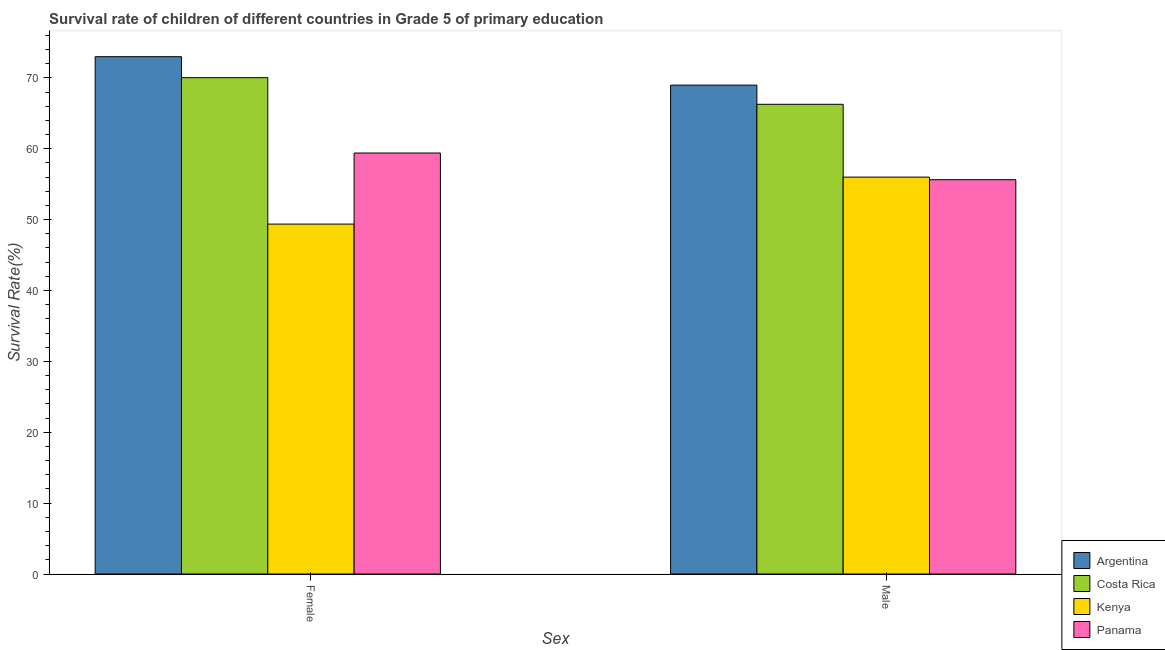How many different coloured bars are there?
Ensure brevity in your answer.  4. Are the number of bars per tick equal to the number of legend labels?
Provide a succinct answer. Yes. Are the number of bars on each tick of the X-axis equal?
Provide a short and direct response. Yes. How many bars are there on the 1st tick from the left?
Provide a succinct answer. 4. How many bars are there on the 1st tick from the right?
Make the answer very short. 4. What is the label of the 1st group of bars from the left?
Provide a succinct answer. Female. What is the survival rate of male students in primary education in Argentina?
Keep it short and to the point. 68.98. Across all countries, what is the maximum survival rate of male students in primary education?
Your answer should be very brief. 68.98. Across all countries, what is the minimum survival rate of male students in primary education?
Give a very brief answer. 55.63. In which country was the survival rate of female students in primary education minimum?
Offer a very short reply. Kenya. What is the total survival rate of female students in primary education in the graph?
Offer a terse response. 251.8. What is the difference between the survival rate of male students in primary education in Panama and that in Costa Rica?
Your answer should be very brief. -10.64. What is the difference between the survival rate of male students in primary education in Costa Rica and the survival rate of female students in primary education in Kenya?
Provide a succinct answer. 16.9. What is the average survival rate of male students in primary education per country?
Give a very brief answer. 61.72. What is the difference between the survival rate of female students in primary education and survival rate of male students in primary education in Argentina?
Provide a short and direct response. 4.01. What is the ratio of the survival rate of male students in primary education in Costa Rica to that in Panama?
Keep it short and to the point. 1.19. What does the 4th bar from the left in Female represents?
Your answer should be compact. Panama. Are all the bars in the graph horizontal?
Make the answer very short. No. What is the difference between two consecutive major ticks on the Y-axis?
Your response must be concise. 10. Are the values on the major ticks of Y-axis written in scientific E-notation?
Keep it short and to the point. No. Does the graph contain any zero values?
Offer a terse response. No. How are the legend labels stacked?
Offer a very short reply. Vertical. What is the title of the graph?
Offer a terse response. Survival rate of children of different countries in Grade 5 of primary education. What is the label or title of the X-axis?
Your answer should be compact. Sex. What is the label or title of the Y-axis?
Your answer should be compact. Survival Rate(%). What is the Survival Rate(%) of Argentina in Female?
Provide a succinct answer. 72.99. What is the Survival Rate(%) of Costa Rica in Female?
Ensure brevity in your answer.  70.03. What is the Survival Rate(%) of Kenya in Female?
Your answer should be compact. 49.37. What is the Survival Rate(%) of Panama in Female?
Provide a short and direct response. 59.4. What is the Survival Rate(%) of Argentina in Male?
Ensure brevity in your answer.  68.98. What is the Survival Rate(%) of Costa Rica in Male?
Ensure brevity in your answer.  66.27. What is the Survival Rate(%) in Kenya in Male?
Make the answer very short. 56. What is the Survival Rate(%) in Panama in Male?
Your answer should be very brief. 55.63. Across all Sex, what is the maximum Survival Rate(%) in Argentina?
Offer a very short reply. 72.99. Across all Sex, what is the maximum Survival Rate(%) in Costa Rica?
Ensure brevity in your answer.  70.03. Across all Sex, what is the maximum Survival Rate(%) of Kenya?
Your answer should be compact. 56. Across all Sex, what is the maximum Survival Rate(%) of Panama?
Offer a very short reply. 59.4. Across all Sex, what is the minimum Survival Rate(%) in Argentina?
Your response must be concise. 68.98. Across all Sex, what is the minimum Survival Rate(%) of Costa Rica?
Your answer should be compact. 66.27. Across all Sex, what is the minimum Survival Rate(%) in Kenya?
Make the answer very short. 49.37. Across all Sex, what is the minimum Survival Rate(%) of Panama?
Give a very brief answer. 55.63. What is the total Survival Rate(%) in Argentina in the graph?
Provide a short and direct response. 141.97. What is the total Survival Rate(%) in Costa Rica in the graph?
Offer a terse response. 136.31. What is the total Survival Rate(%) in Kenya in the graph?
Your answer should be compact. 105.37. What is the total Survival Rate(%) of Panama in the graph?
Ensure brevity in your answer.  115.04. What is the difference between the Survival Rate(%) in Argentina in Female and that in Male?
Offer a terse response. 4.01. What is the difference between the Survival Rate(%) in Costa Rica in Female and that in Male?
Offer a terse response. 3.76. What is the difference between the Survival Rate(%) in Kenya in Female and that in Male?
Provide a succinct answer. -6.63. What is the difference between the Survival Rate(%) of Panama in Female and that in Male?
Offer a very short reply. 3.77. What is the difference between the Survival Rate(%) in Argentina in Female and the Survival Rate(%) in Costa Rica in Male?
Make the answer very short. 6.72. What is the difference between the Survival Rate(%) of Argentina in Female and the Survival Rate(%) of Kenya in Male?
Your answer should be very brief. 16.99. What is the difference between the Survival Rate(%) in Argentina in Female and the Survival Rate(%) in Panama in Male?
Your answer should be compact. 17.36. What is the difference between the Survival Rate(%) of Costa Rica in Female and the Survival Rate(%) of Kenya in Male?
Ensure brevity in your answer.  14.03. What is the difference between the Survival Rate(%) in Costa Rica in Female and the Survival Rate(%) in Panama in Male?
Offer a very short reply. 14.4. What is the difference between the Survival Rate(%) in Kenya in Female and the Survival Rate(%) in Panama in Male?
Make the answer very short. -6.26. What is the average Survival Rate(%) of Argentina per Sex?
Provide a short and direct response. 70.99. What is the average Survival Rate(%) in Costa Rica per Sex?
Your response must be concise. 68.15. What is the average Survival Rate(%) of Kenya per Sex?
Offer a very short reply. 52.69. What is the average Survival Rate(%) of Panama per Sex?
Offer a terse response. 57.52. What is the difference between the Survival Rate(%) of Argentina and Survival Rate(%) of Costa Rica in Female?
Your answer should be very brief. 2.96. What is the difference between the Survival Rate(%) of Argentina and Survival Rate(%) of Kenya in Female?
Your answer should be very brief. 23.62. What is the difference between the Survival Rate(%) of Argentina and Survival Rate(%) of Panama in Female?
Make the answer very short. 13.59. What is the difference between the Survival Rate(%) in Costa Rica and Survival Rate(%) in Kenya in Female?
Provide a short and direct response. 20.66. What is the difference between the Survival Rate(%) in Costa Rica and Survival Rate(%) in Panama in Female?
Ensure brevity in your answer.  10.63. What is the difference between the Survival Rate(%) of Kenya and Survival Rate(%) of Panama in Female?
Make the answer very short. -10.03. What is the difference between the Survival Rate(%) in Argentina and Survival Rate(%) in Costa Rica in Male?
Your response must be concise. 2.71. What is the difference between the Survival Rate(%) in Argentina and Survival Rate(%) in Kenya in Male?
Your response must be concise. 12.98. What is the difference between the Survival Rate(%) in Argentina and Survival Rate(%) in Panama in Male?
Provide a short and direct response. 13.35. What is the difference between the Survival Rate(%) in Costa Rica and Survival Rate(%) in Kenya in Male?
Your answer should be very brief. 10.27. What is the difference between the Survival Rate(%) in Costa Rica and Survival Rate(%) in Panama in Male?
Give a very brief answer. 10.64. What is the difference between the Survival Rate(%) in Kenya and Survival Rate(%) in Panama in Male?
Keep it short and to the point. 0.36. What is the ratio of the Survival Rate(%) of Argentina in Female to that in Male?
Provide a succinct answer. 1.06. What is the ratio of the Survival Rate(%) of Costa Rica in Female to that in Male?
Offer a terse response. 1.06. What is the ratio of the Survival Rate(%) of Kenya in Female to that in Male?
Your response must be concise. 0.88. What is the ratio of the Survival Rate(%) in Panama in Female to that in Male?
Offer a terse response. 1.07. What is the difference between the highest and the second highest Survival Rate(%) of Argentina?
Ensure brevity in your answer.  4.01. What is the difference between the highest and the second highest Survival Rate(%) in Costa Rica?
Make the answer very short. 3.76. What is the difference between the highest and the second highest Survival Rate(%) in Kenya?
Ensure brevity in your answer.  6.63. What is the difference between the highest and the second highest Survival Rate(%) of Panama?
Keep it short and to the point. 3.77. What is the difference between the highest and the lowest Survival Rate(%) of Argentina?
Make the answer very short. 4.01. What is the difference between the highest and the lowest Survival Rate(%) in Costa Rica?
Your answer should be compact. 3.76. What is the difference between the highest and the lowest Survival Rate(%) of Kenya?
Offer a terse response. 6.63. What is the difference between the highest and the lowest Survival Rate(%) in Panama?
Give a very brief answer. 3.77. 